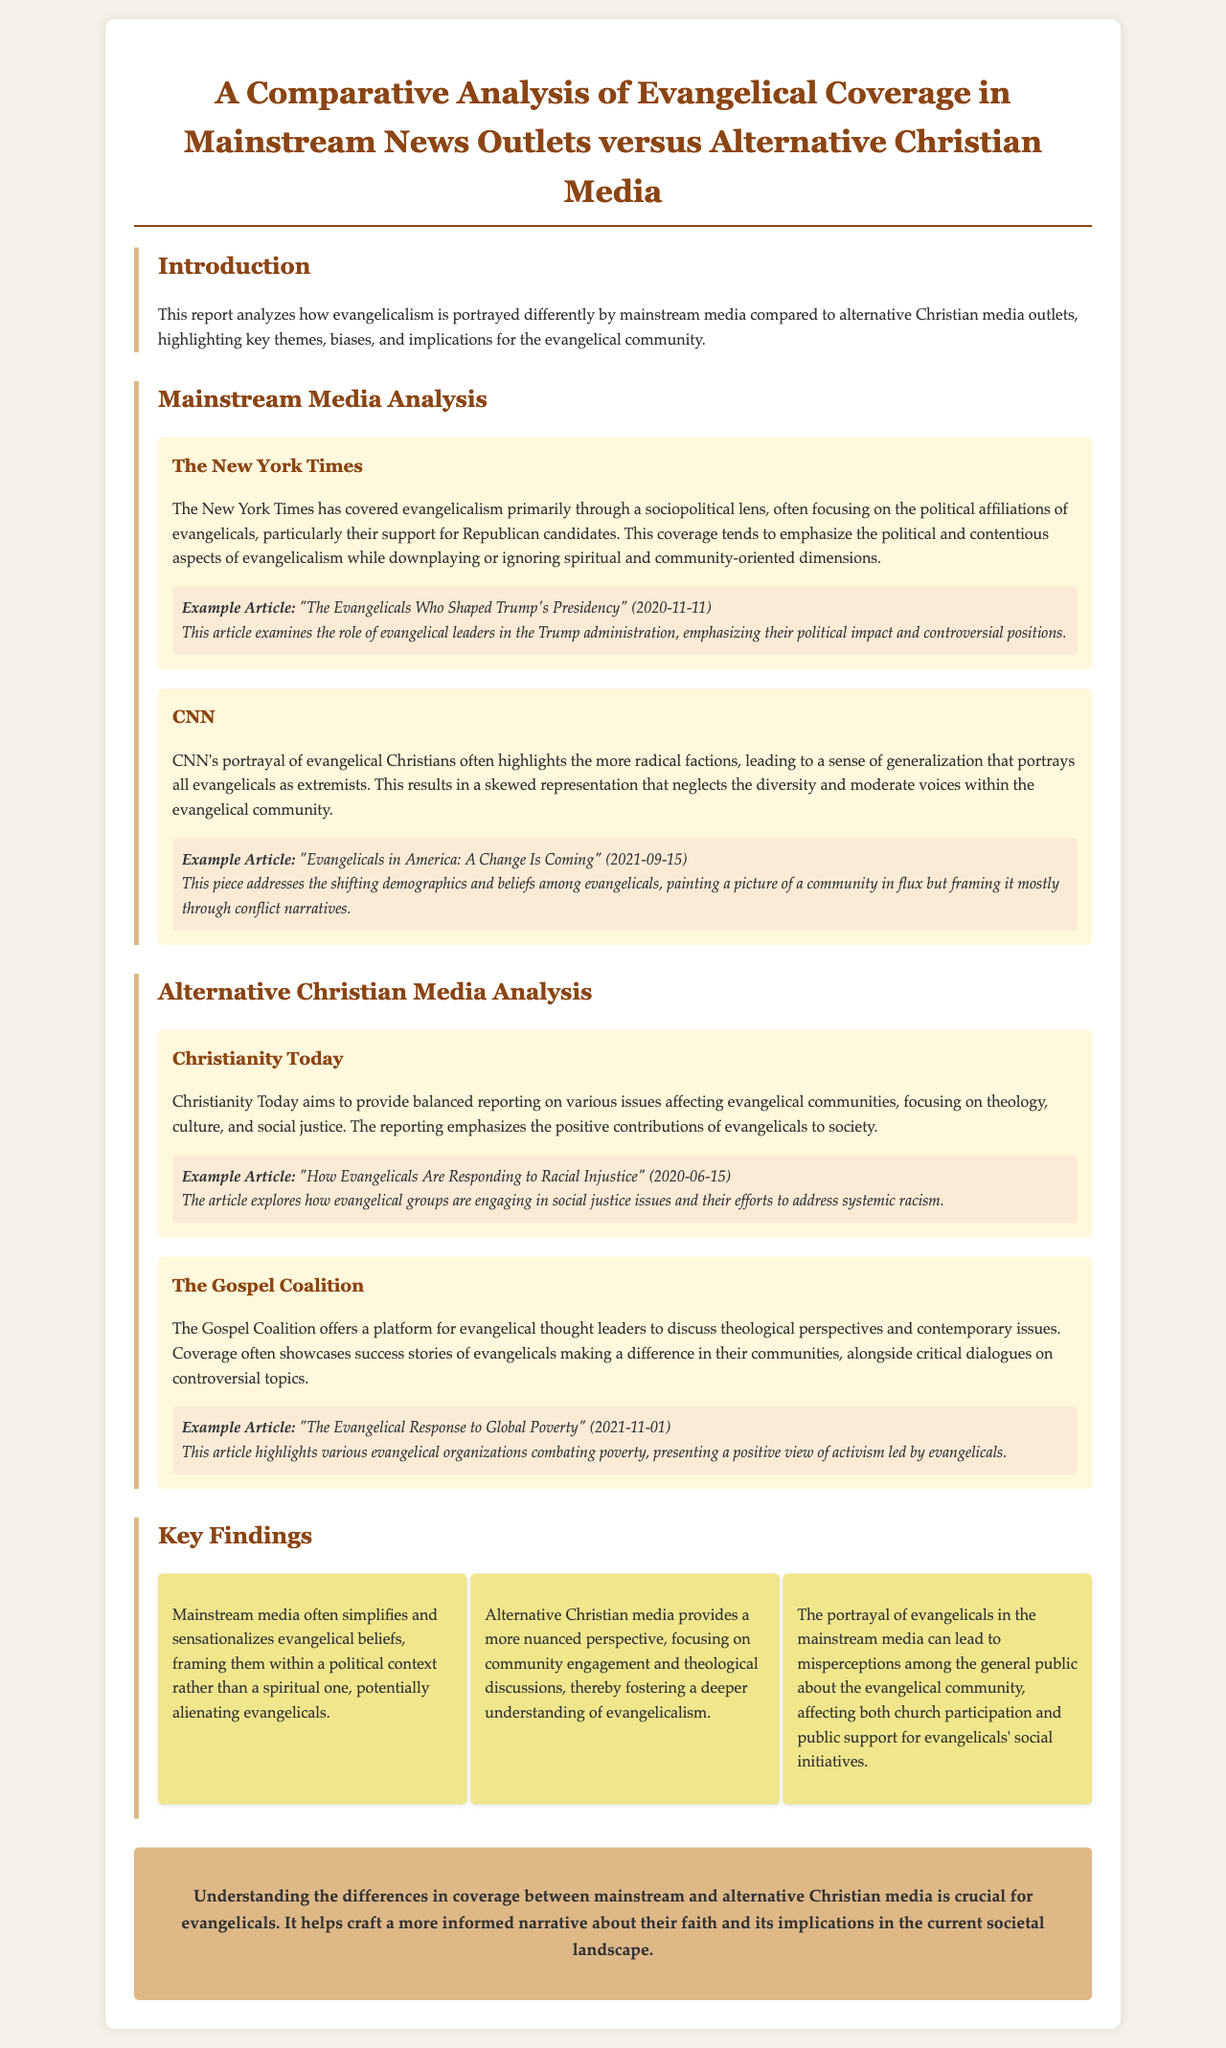What is the title of the report? The title of the report is stated at the top of the document, summarizing the focus of the analysis.
Answer: A Comparative Analysis of Evangelical Coverage in Mainstream News Outlets versus Alternative Christian Media Who is the author of the example article from The New York Times? The document provides an example article from The New York Times along with its publication date but does not specify an author.
Answer: Not provided What date was the example article from CNN published? The publication date of the CNN article is mentioned in the document and is essential for understanding the context of the coverage.
Answer: 2021-09-15 What focus does Christianity Today have in its coverage? The document outlines the focus of Christianity Today regarding its reporting on evangelical issues, emphasizing the type of content it produces.
Answer: Balanced reporting on various issues affecting evangelical communities What common aspect characterizes mainstream media coverage of evangelicalism? The report highlights a pattern in how mainstream media chooses to represent evangelicals, particularly in terms of their framing.
Answer: Simplifies and sensationalizes evangelical beliefs What is one of the key findings of the report? The section on key findings summarizes several observations about the differences in media coverage, which are crucial for understanding the implications for evangelicals.
Answer: The portrayal of evangelicals in the mainstream media can lead to misperceptions among the general public Which outlet focuses on theological discussions among evangelical thought leaders? The report mentions several alternative media outlets, pointing out their unique approaches to covering evangelicalism, including theological discussions.
Answer: The Gospel Coalition What is the overall conclusion of the report? The conclusion reflects the implications of the findings discussed in the analysis, emphasizing its importance to the evangelical community.
Answer: Understanding the differences in coverage between mainstream and alternative Christian media is crucial for evangelicals 